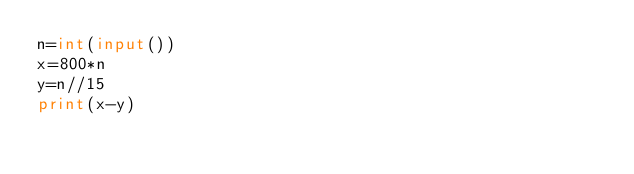<code> <loc_0><loc_0><loc_500><loc_500><_Python_>n=int(input())
x=800*n
y=n//15
print(x-y)</code> 